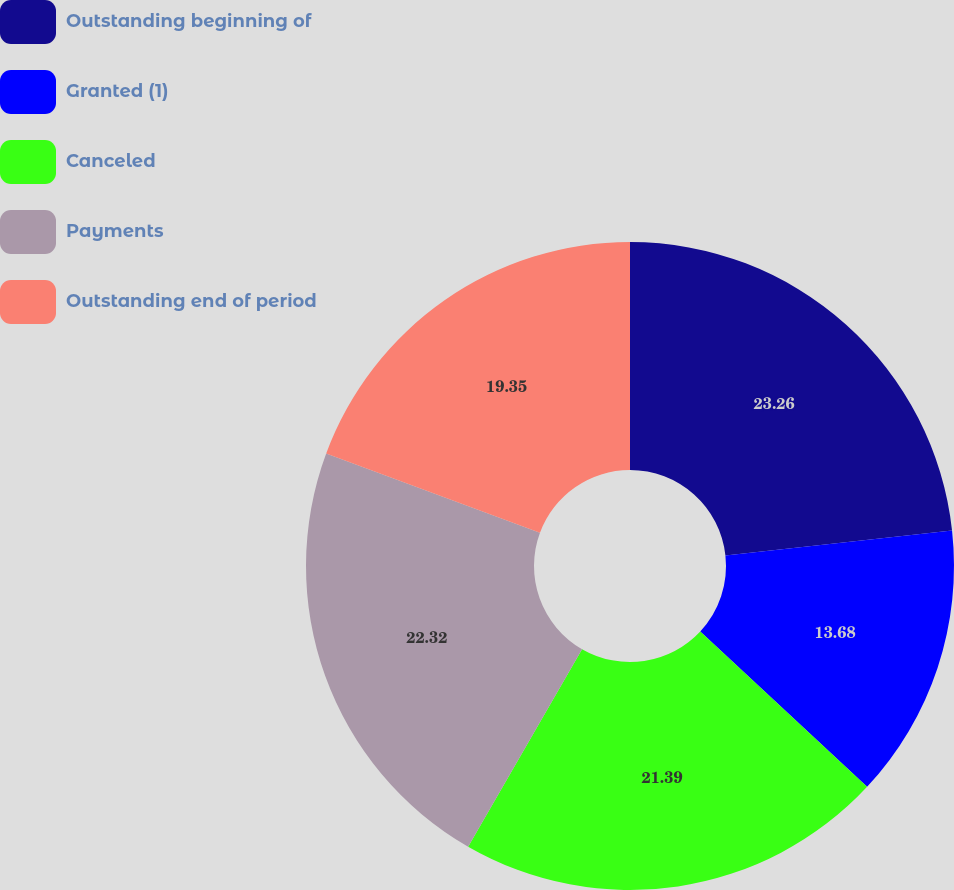Convert chart. <chart><loc_0><loc_0><loc_500><loc_500><pie_chart><fcel>Outstanding beginning of<fcel>Granted (1)<fcel>Canceled<fcel>Payments<fcel>Outstanding end of period<nl><fcel>23.25%<fcel>13.68%<fcel>21.39%<fcel>22.32%<fcel>19.35%<nl></chart> 